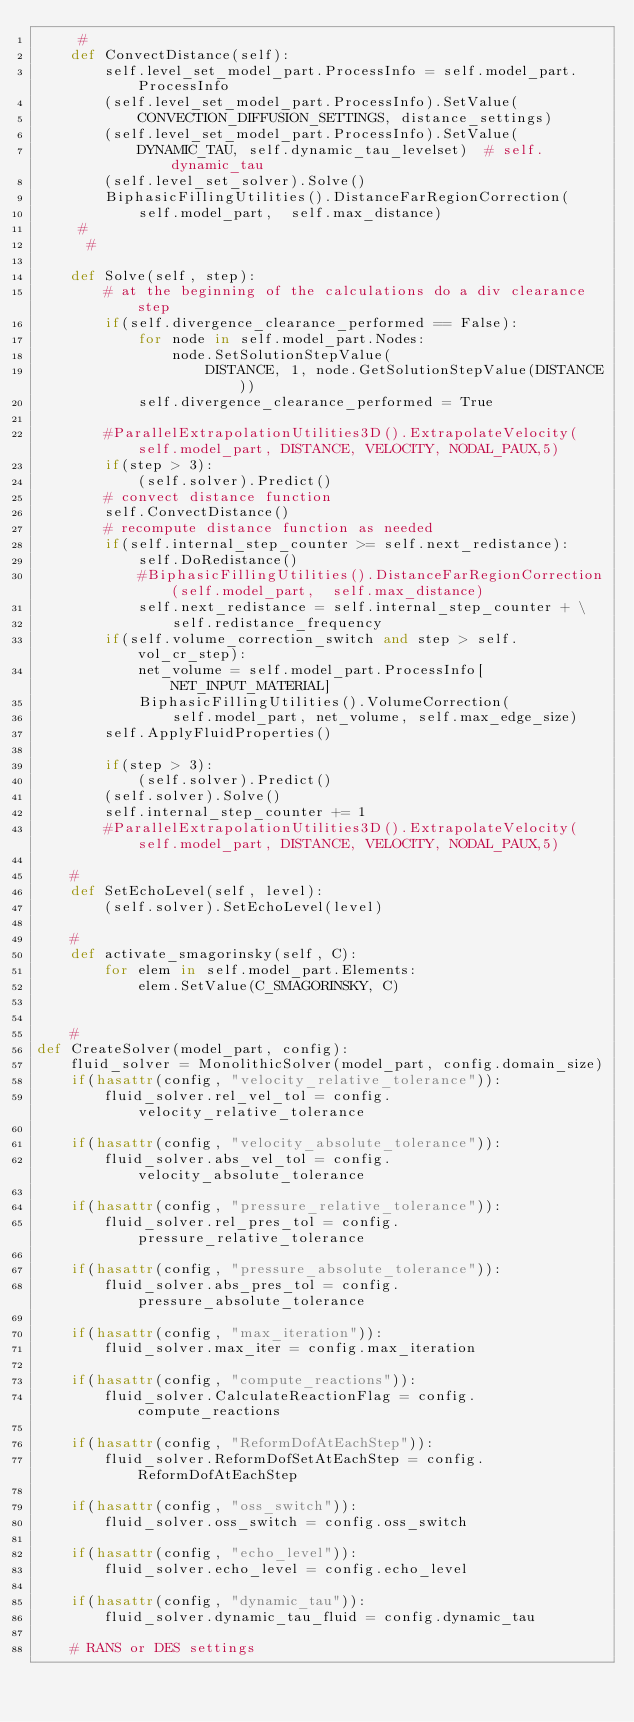<code> <loc_0><loc_0><loc_500><loc_500><_Python_>     #
    def ConvectDistance(self):
        self.level_set_model_part.ProcessInfo = self.model_part.ProcessInfo
        (self.level_set_model_part.ProcessInfo).SetValue(
            CONVECTION_DIFFUSION_SETTINGS, distance_settings)
        (self.level_set_model_part.ProcessInfo).SetValue(
            DYNAMIC_TAU, self.dynamic_tau_levelset)  # self.dynamic_tau
        (self.level_set_solver).Solve()
        BiphasicFillingUtilities().DistanceFarRegionCorrection(
            self.model_part,  self.max_distance)
     #
      #

    def Solve(self, step):
        # at the beginning of the calculations do a div clearance step
        if(self.divergence_clearance_performed == False):
            for node in self.model_part.Nodes:
                node.SetSolutionStepValue(
                    DISTANCE, 1, node.GetSolutionStepValue(DISTANCE))
            self.divergence_clearance_performed = True

        #ParallelExtrapolationUtilities3D().ExtrapolateVelocity(self.model_part, DISTANCE, VELOCITY, NODAL_PAUX,5)
        if(step > 3):
            (self.solver).Predict()
        # convect distance function
        self.ConvectDistance()
        # recompute distance function as needed
        if(self.internal_step_counter >= self.next_redistance):
            self.DoRedistance()
            #BiphasicFillingUtilities().DistanceFarRegionCorrection(self.model_part,  self.max_distance)
            self.next_redistance = self.internal_step_counter + \
                self.redistance_frequency
        if(self.volume_correction_switch and step > self.vol_cr_step):
            net_volume = self.model_part.ProcessInfo[NET_INPUT_MATERIAL]
            BiphasicFillingUtilities().VolumeCorrection(
                self.model_part, net_volume, self.max_edge_size)
        self.ApplyFluidProperties()

        if(step > 3):
            (self.solver).Predict()
        (self.solver).Solve()
        self.internal_step_counter += 1
        #ParallelExtrapolationUtilities3D().ExtrapolateVelocity(self.model_part, DISTANCE, VELOCITY, NODAL_PAUX,5)

    #
    def SetEchoLevel(self, level):
        (self.solver).SetEchoLevel(level)

    #
    def activate_smagorinsky(self, C):
        for elem in self.model_part.Elements:
            elem.SetValue(C_SMAGORINSKY, C)


    #
def CreateSolver(model_part, config):
    fluid_solver = MonolithicSolver(model_part, config.domain_size)
    if(hasattr(config, "velocity_relative_tolerance")):
        fluid_solver.rel_vel_tol = config.velocity_relative_tolerance

    if(hasattr(config, "velocity_absolute_tolerance")):
        fluid_solver.abs_vel_tol = config.velocity_absolute_tolerance

    if(hasattr(config, "pressure_relative_tolerance")):
        fluid_solver.rel_pres_tol = config.pressure_relative_tolerance

    if(hasattr(config, "pressure_absolute_tolerance")):
        fluid_solver.abs_pres_tol = config.pressure_absolute_tolerance

    if(hasattr(config, "max_iteration")):
        fluid_solver.max_iter = config.max_iteration

    if(hasattr(config, "compute_reactions")):
        fluid_solver.CalculateReactionFlag = config.compute_reactions

    if(hasattr(config, "ReformDofAtEachStep")):
        fluid_solver.ReformDofSetAtEachStep = config.ReformDofAtEachStep

    if(hasattr(config, "oss_switch")):
        fluid_solver.oss_switch = config.oss_switch

    if(hasattr(config, "echo_level")):
        fluid_solver.echo_level = config.echo_level

    if(hasattr(config, "dynamic_tau")):
        fluid_solver.dynamic_tau_fluid = config.dynamic_tau

    # RANS or DES settings</code> 